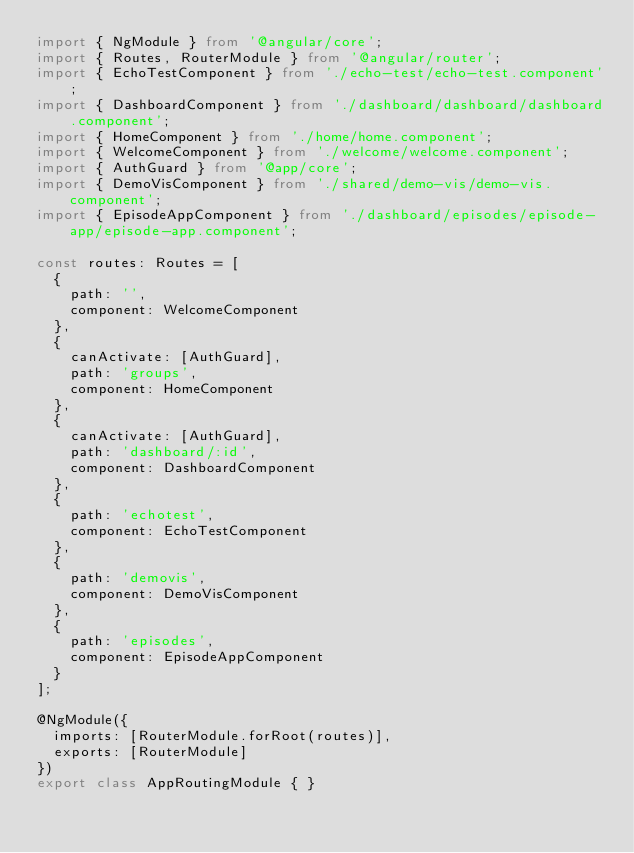<code> <loc_0><loc_0><loc_500><loc_500><_TypeScript_>import { NgModule } from '@angular/core';
import { Routes, RouterModule } from '@angular/router';
import { EchoTestComponent } from './echo-test/echo-test.component';
import { DashboardComponent } from './dashboard/dashboard/dashboard.component';
import { HomeComponent } from './home/home.component';
import { WelcomeComponent } from './welcome/welcome.component';
import { AuthGuard } from '@app/core';
import { DemoVisComponent } from './shared/demo-vis/demo-vis.component';
import { EpisodeAppComponent } from './dashboard/episodes/episode-app/episode-app.component';

const routes: Routes = [
  {
    path: '',
    component: WelcomeComponent
  },
  {
    canActivate: [AuthGuard],
    path: 'groups',
    component: HomeComponent
  },
  {
    canActivate: [AuthGuard],
    path: 'dashboard/:id',
    component: DashboardComponent
  },
  {
    path: 'echotest',
    component: EchoTestComponent
  },
  {
    path: 'demovis',
    component: DemoVisComponent
  },
  {
    path: 'episodes',
    component: EpisodeAppComponent
  }
];

@NgModule({
  imports: [RouterModule.forRoot(routes)],
  exports: [RouterModule]
})
export class AppRoutingModule { }
</code> 